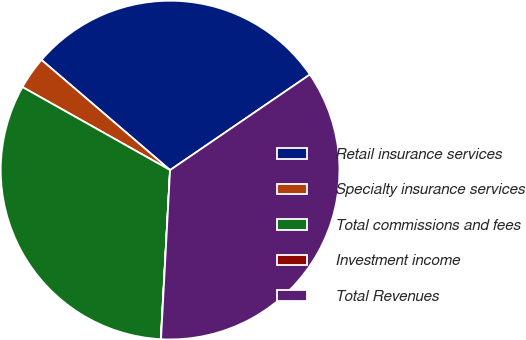Convert chart. <chart><loc_0><loc_0><loc_500><loc_500><pie_chart><fcel>Retail insurance services<fcel>Specialty insurance services<fcel>Total commissions and fees<fcel>Investment income<fcel>Total Revenues<nl><fcel>29.18%<fcel>3.12%<fcel>32.28%<fcel>0.02%<fcel>35.39%<nl></chart> 